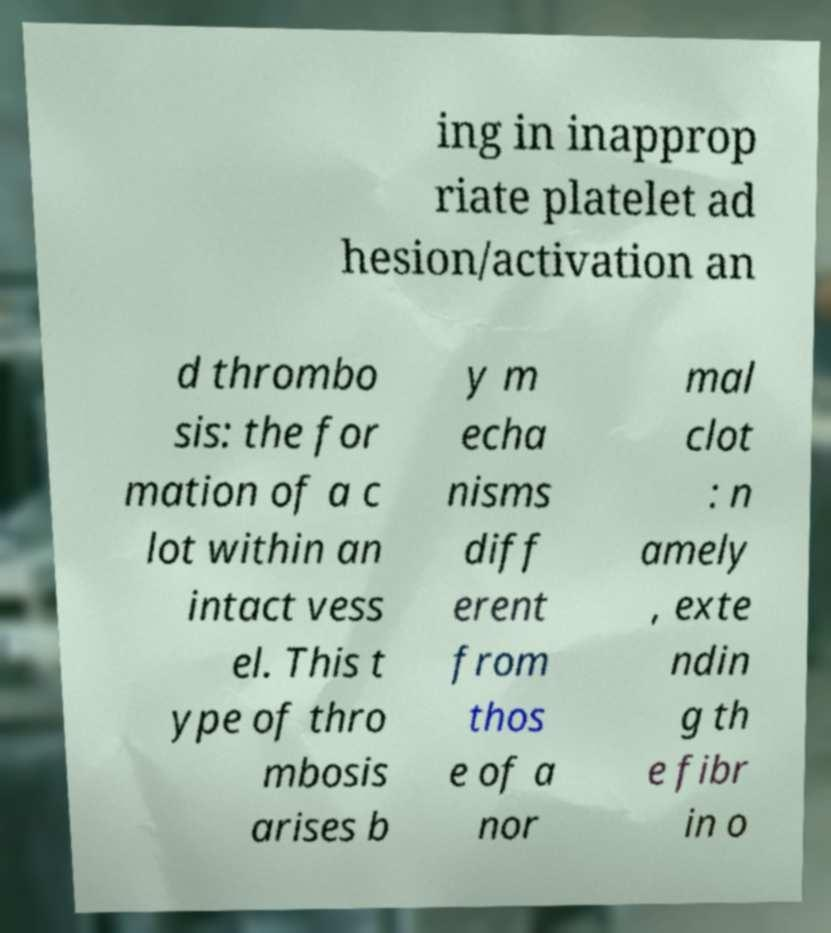Could you assist in decoding the text presented in this image and type it out clearly? ing in inapprop riate platelet ad hesion/activation an d thrombo sis: the for mation of a c lot within an intact vess el. This t ype of thro mbosis arises b y m echa nisms diff erent from thos e of a nor mal clot : n amely , exte ndin g th e fibr in o 